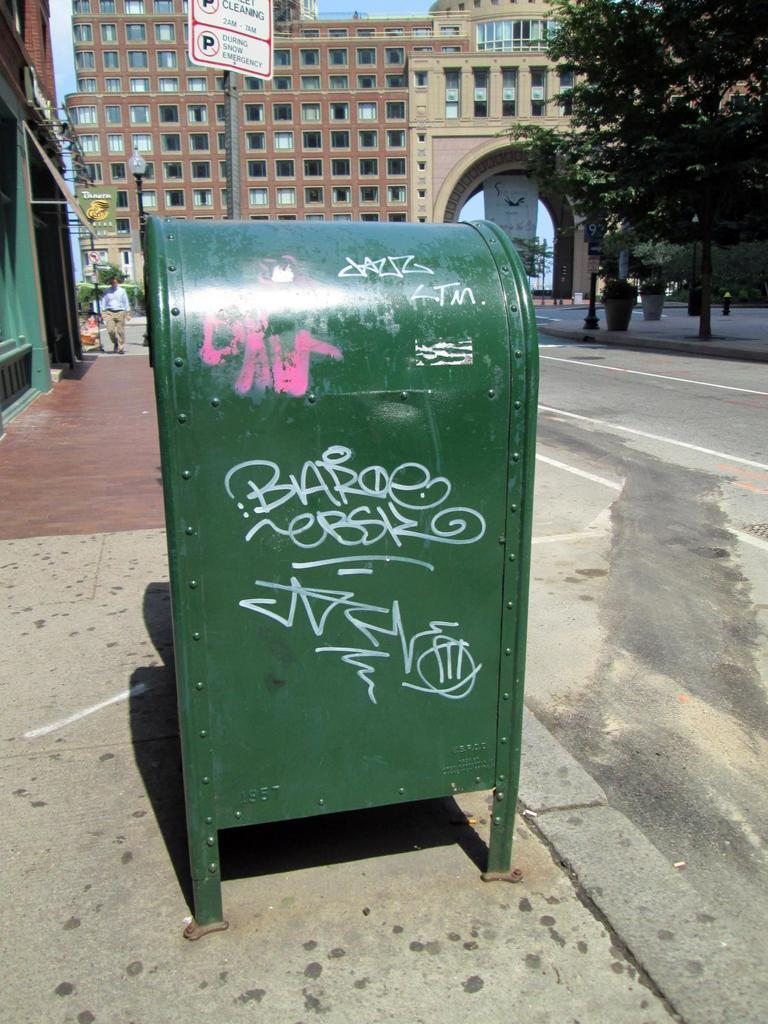<image>
Write a terse but informative summary of the picture. A trash bin in a street has the graffit Barboe scrawled on it. 